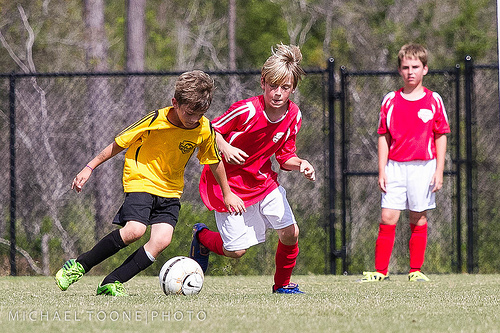<image>
Can you confirm if the ball is behind the boy? No. The ball is not behind the boy. From this viewpoint, the ball appears to be positioned elsewhere in the scene. Is there a boy to the right of the ball? No. The boy is not to the right of the ball. The horizontal positioning shows a different relationship. 